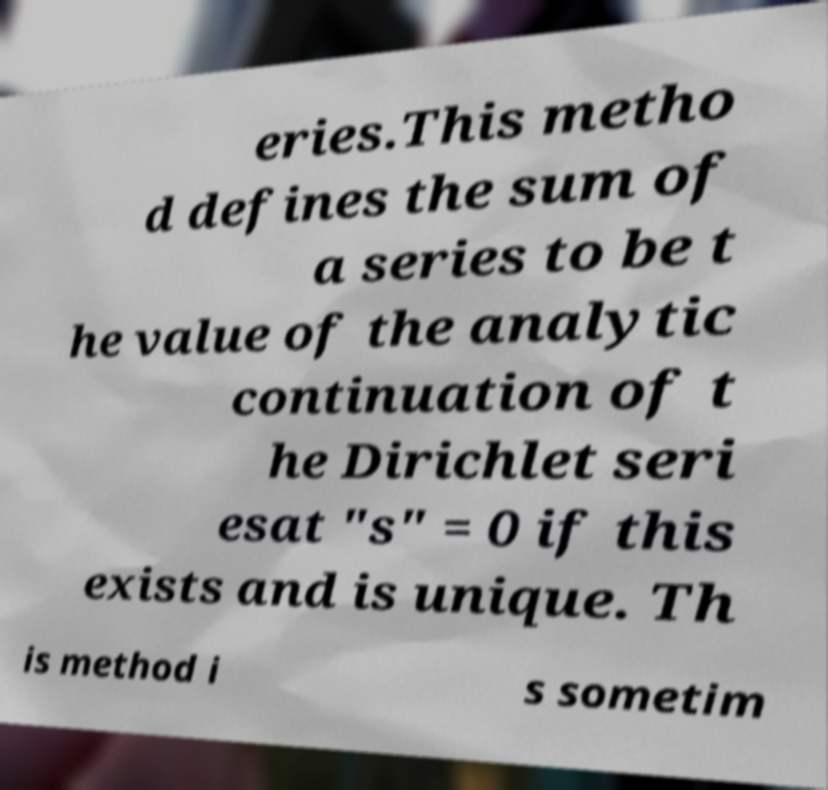Can you accurately transcribe the text from the provided image for me? eries.This metho d defines the sum of a series to be t he value of the analytic continuation of t he Dirichlet seri esat "s" = 0 if this exists and is unique. Th is method i s sometim 